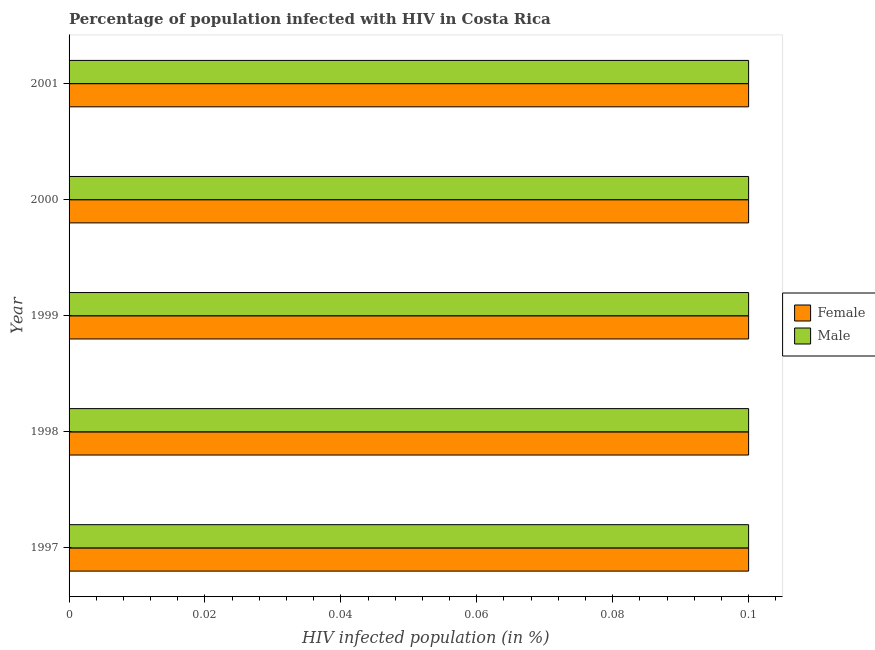How many bars are there on the 2nd tick from the top?
Give a very brief answer. 2. What is the label of the 3rd group of bars from the top?
Your answer should be compact. 1999. In how many cases, is the number of bars for a given year not equal to the number of legend labels?
Ensure brevity in your answer.  0. In which year was the percentage of males who are infected with hiv minimum?
Give a very brief answer. 1997. What is the total percentage of males who are infected with hiv in the graph?
Provide a succinct answer. 0.5. What is the difference between the percentage of females who are infected with hiv in 1998 and the percentage of males who are infected with hiv in 2000?
Give a very brief answer. 0. Is the percentage of females who are infected with hiv in 1999 less than that in 2001?
Make the answer very short. No. In how many years, is the percentage of females who are infected with hiv greater than the average percentage of females who are infected with hiv taken over all years?
Give a very brief answer. 0. Is the sum of the percentage of males who are infected with hiv in 1997 and 2001 greater than the maximum percentage of females who are infected with hiv across all years?
Keep it short and to the point. Yes. What does the 2nd bar from the bottom in 1997 represents?
Keep it short and to the point. Male. How many years are there in the graph?
Offer a terse response. 5. What is the difference between two consecutive major ticks on the X-axis?
Provide a succinct answer. 0.02. Are the values on the major ticks of X-axis written in scientific E-notation?
Give a very brief answer. No. Does the graph contain any zero values?
Offer a terse response. No. Where does the legend appear in the graph?
Offer a terse response. Center right. How many legend labels are there?
Provide a succinct answer. 2. How are the legend labels stacked?
Offer a very short reply. Vertical. What is the title of the graph?
Offer a very short reply. Percentage of population infected with HIV in Costa Rica. Does "By country of asylum" appear as one of the legend labels in the graph?
Keep it short and to the point. No. What is the label or title of the X-axis?
Ensure brevity in your answer.  HIV infected population (in %). What is the label or title of the Y-axis?
Provide a succinct answer. Year. What is the HIV infected population (in %) of Female in 1999?
Your response must be concise. 0.1. What is the HIV infected population (in %) in Male in 1999?
Offer a very short reply. 0.1. What is the HIV infected population (in %) in Female in 2000?
Offer a very short reply. 0.1. What is the HIV infected population (in %) in Male in 2000?
Make the answer very short. 0.1. What is the HIV infected population (in %) of Male in 2001?
Provide a succinct answer. 0.1. Across all years, what is the maximum HIV infected population (in %) of Male?
Make the answer very short. 0.1. Across all years, what is the minimum HIV infected population (in %) in Female?
Your answer should be very brief. 0.1. What is the total HIV infected population (in %) of Female in the graph?
Your answer should be compact. 0.5. What is the total HIV infected population (in %) of Male in the graph?
Your answer should be very brief. 0.5. What is the difference between the HIV infected population (in %) of Female in 1997 and that in 1998?
Provide a short and direct response. 0. What is the difference between the HIV infected population (in %) of Female in 1997 and that in 1999?
Provide a short and direct response. 0. What is the difference between the HIV infected population (in %) of Male in 1997 and that in 1999?
Make the answer very short. 0. What is the difference between the HIV infected population (in %) in Female in 1997 and that in 2000?
Your response must be concise. 0. What is the difference between the HIV infected population (in %) of Male in 1997 and that in 2000?
Offer a very short reply. 0. What is the difference between the HIV infected population (in %) in Male in 1997 and that in 2001?
Keep it short and to the point. 0. What is the difference between the HIV infected population (in %) of Female in 1998 and that in 1999?
Make the answer very short. 0. What is the difference between the HIV infected population (in %) in Female in 1998 and that in 2000?
Offer a very short reply. 0. What is the difference between the HIV infected population (in %) of Female in 1998 and that in 2001?
Your answer should be very brief. 0. What is the difference between the HIV infected population (in %) in Male in 1999 and that in 2001?
Make the answer very short. 0. What is the difference between the HIV infected population (in %) of Female in 1997 and the HIV infected population (in %) of Male in 1999?
Your answer should be very brief. 0. What is the difference between the HIV infected population (in %) in Female in 1997 and the HIV infected population (in %) in Male in 2001?
Give a very brief answer. 0. What is the difference between the HIV infected population (in %) of Female in 1998 and the HIV infected population (in %) of Male in 2001?
Provide a short and direct response. 0. What is the difference between the HIV infected population (in %) of Female in 1999 and the HIV infected population (in %) of Male in 2000?
Your answer should be compact. 0. What is the difference between the HIV infected population (in %) in Female in 2000 and the HIV infected population (in %) in Male in 2001?
Give a very brief answer. 0. In the year 2000, what is the difference between the HIV infected population (in %) in Female and HIV infected population (in %) in Male?
Give a very brief answer. 0. What is the ratio of the HIV infected population (in %) of Female in 1997 to that in 1998?
Your answer should be very brief. 1. What is the ratio of the HIV infected population (in %) in Male in 1998 to that in 1999?
Your answer should be very brief. 1. What is the ratio of the HIV infected population (in %) in Female in 1998 to that in 2000?
Your answer should be very brief. 1. What is the ratio of the HIV infected population (in %) of Male in 1998 to that in 2000?
Ensure brevity in your answer.  1. What is the ratio of the HIV infected population (in %) of Female in 1998 to that in 2001?
Give a very brief answer. 1. What is the ratio of the HIV infected population (in %) in Female in 1999 to that in 2000?
Keep it short and to the point. 1. What is the ratio of the HIV infected population (in %) of Male in 1999 to that in 2000?
Make the answer very short. 1. What is the ratio of the HIV infected population (in %) in Female in 1999 to that in 2001?
Provide a succinct answer. 1. What is the ratio of the HIV infected population (in %) of Male in 2000 to that in 2001?
Provide a short and direct response. 1. What is the difference between the highest and the second highest HIV infected population (in %) of Female?
Provide a short and direct response. 0. What is the difference between the highest and the lowest HIV infected population (in %) in Female?
Offer a terse response. 0. 